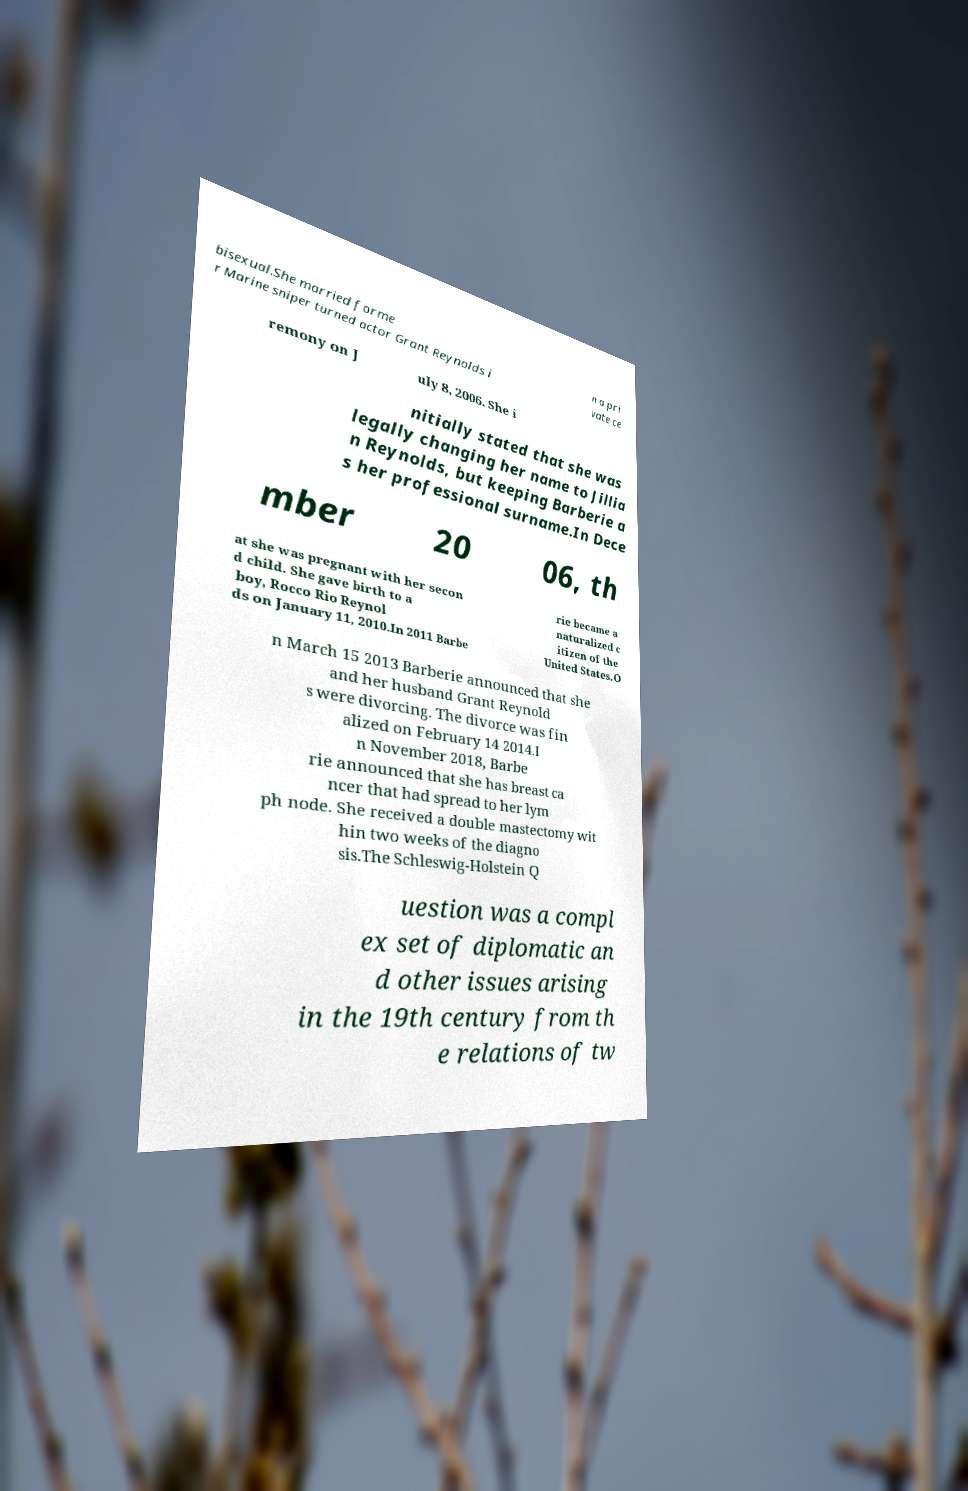There's text embedded in this image that I need extracted. Can you transcribe it verbatim? bisexual.She married forme r Marine sniper turned actor Grant Reynolds i n a pri vate ce remony on J uly 8, 2006. She i nitially stated that she was legally changing her name to Jillia n Reynolds, but keeping Barberie a s her professional surname.In Dece mber 20 06, th at she was pregnant with her secon d child. She gave birth to a boy, Rocco Rio Reynol ds on January 11, 2010.In 2011 Barbe rie became a naturalized c itizen of the United States.O n March 15 2013 Barberie announced that she and her husband Grant Reynold s were divorcing. The divorce was fin alized on February 14 2014.I n November 2018, Barbe rie announced that she has breast ca ncer that had spread to her lym ph node. She received a double mastectomy wit hin two weeks of the diagno sis.The Schleswig-Holstein Q uestion was a compl ex set of diplomatic an d other issues arising in the 19th century from th e relations of tw 